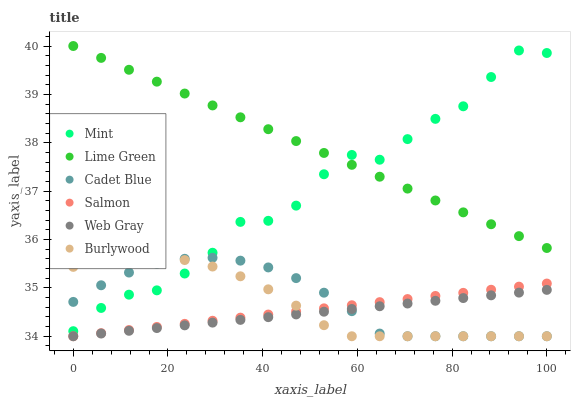Does Web Gray have the minimum area under the curve?
Answer yes or no. Yes. Does Lime Green have the maximum area under the curve?
Answer yes or no. Yes. Does Burlywood have the minimum area under the curve?
Answer yes or no. No. Does Burlywood have the maximum area under the curve?
Answer yes or no. No. Is Salmon the smoothest?
Answer yes or no. Yes. Is Mint the roughest?
Answer yes or no. Yes. Is Burlywood the smoothest?
Answer yes or no. No. Is Burlywood the roughest?
Answer yes or no. No. Does Web Gray have the lowest value?
Answer yes or no. Yes. Does Mint have the lowest value?
Answer yes or no. No. Does Lime Green have the highest value?
Answer yes or no. Yes. Does Burlywood have the highest value?
Answer yes or no. No. Is Salmon less than Mint?
Answer yes or no. Yes. Is Lime Green greater than Salmon?
Answer yes or no. Yes. Does Burlywood intersect Mint?
Answer yes or no. Yes. Is Burlywood less than Mint?
Answer yes or no. No. Is Burlywood greater than Mint?
Answer yes or no. No. Does Salmon intersect Mint?
Answer yes or no. No. 